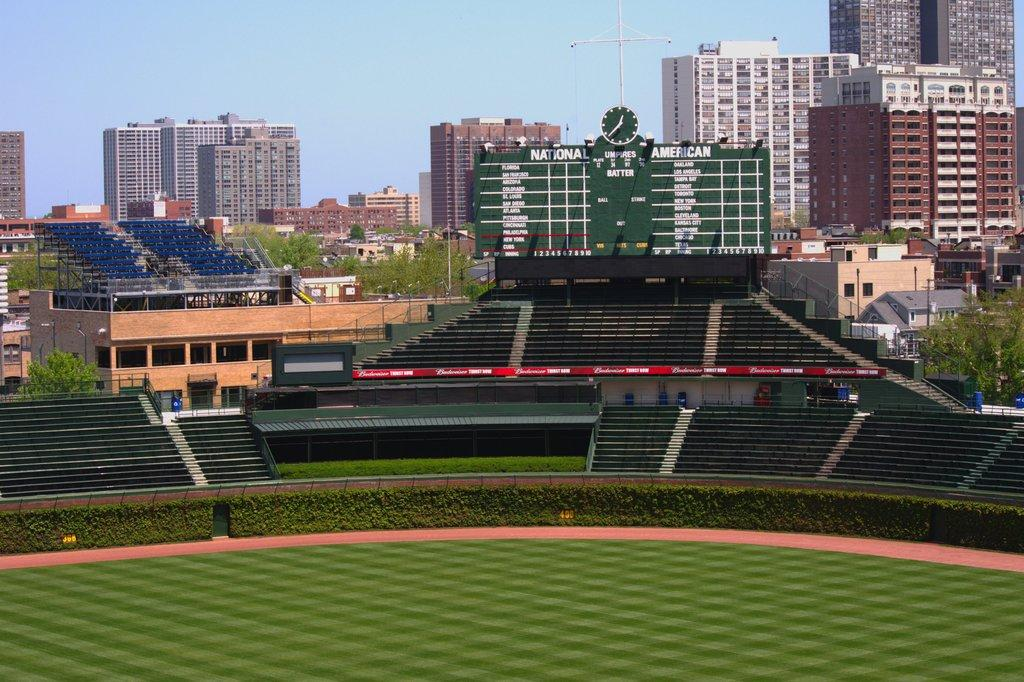What can be seen in the sky in the image? The sky is visible in the image, but no specific details about the sky can be determined from the provided facts. What type of structures are in the image? There are buildings in the image. What other natural elements are present in the image? Trees are present in the image. Can you describe the board in the image? There is a board with a clock and some text in the image. What architectural features can be seen in the image? Staircases and fences are visible in the image. What type of vegetation is present in the image? Plants are in the image. What other objects can be seen in the image? Poles are visible in the image, and there are a few other objects as well. What is the opinion of the daughter about the boot in the image? There is no daughter or boot present in the image, so it is not possible to answer this question. 